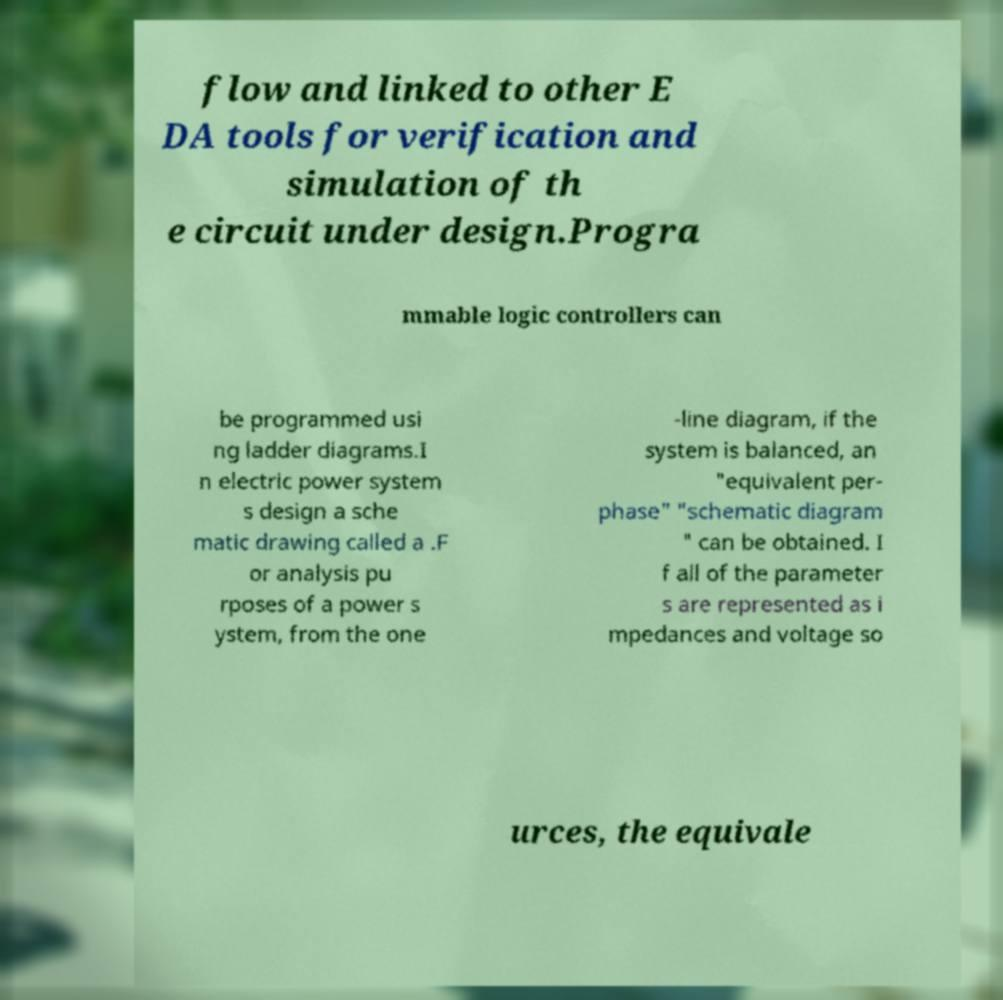For documentation purposes, I need the text within this image transcribed. Could you provide that? flow and linked to other E DA tools for verification and simulation of th e circuit under design.Progra mmable logic controllers can be programmed usi ng ladder diagrams.I n electric power system s design a sche matic drawing called a .F or analysis pu rposes of a power s ystem, from the one -line diagram, if the system is balanced, an "equivalent per- phase" "schematic diagram " can be obtained. I f all of the parameter s are represented as i mpedances and voltage so urces, the equivale 